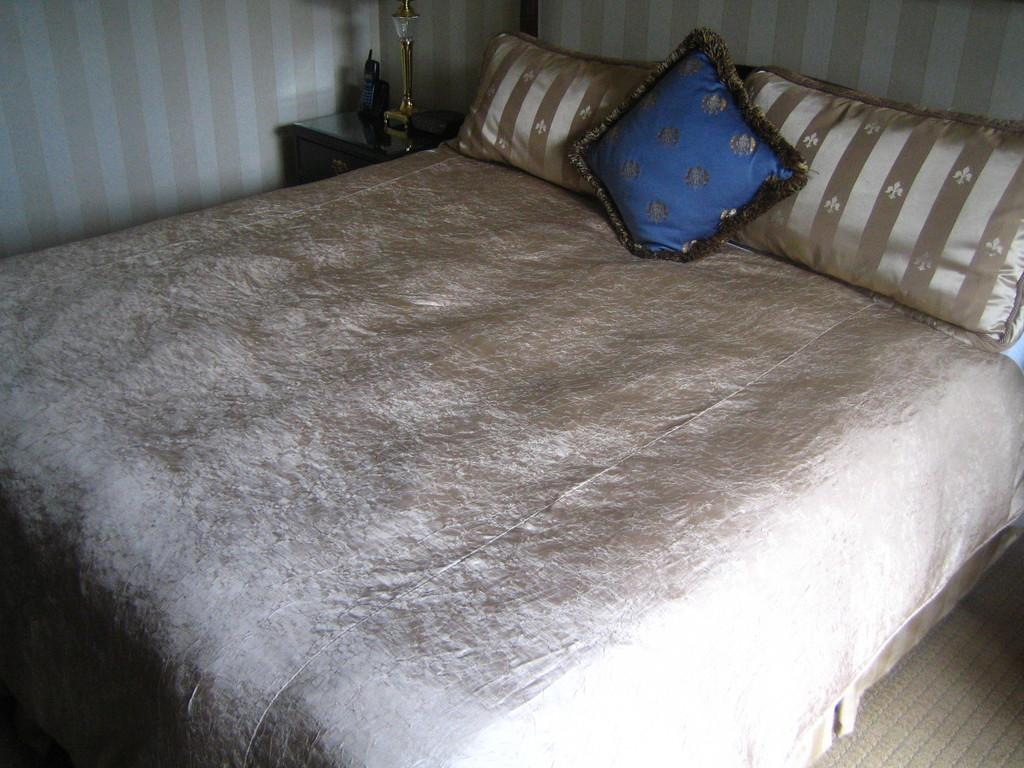What piece of furniture is present in the image? There is a bed in the image. What is placed on the bed? There are pillows on the bed. What can be seen in the background of the image? There is a wall in the background of the image. What type of ray can be seen swimming in the bed? There is no ray present in the image; it features a bed with pillows and a wall in the background. 